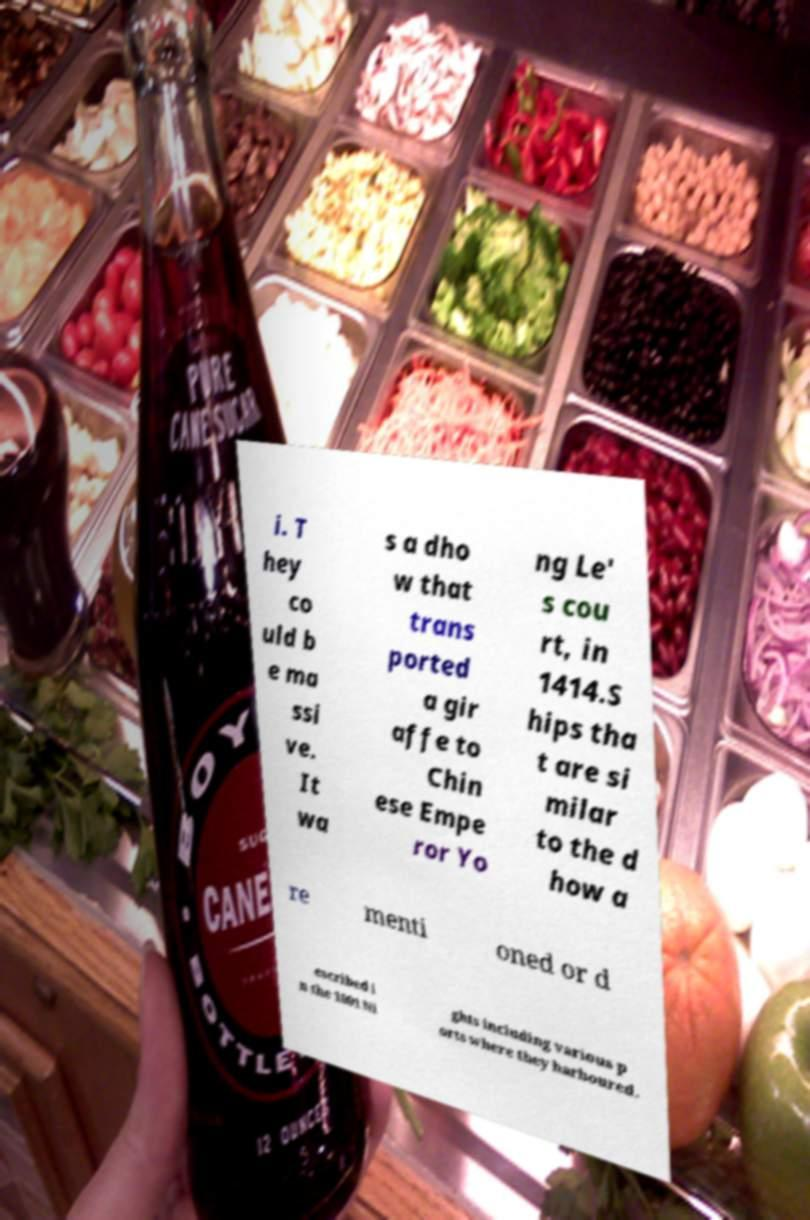Can you read and provide the text displayed in the image?This photo seems to have some interesting text. Can you extract and type it out for me? i. T hey co uld b e ma ssi ve. It wa s a dho w that trans ported a gir affe to Chin ese Empe ror Yo ng Le' s cou rt, in 1414.S hips tha t are si milar to the d how a re menti oned or d escribed i n the 1001 Ni ghts including various p orts where they harboured. 